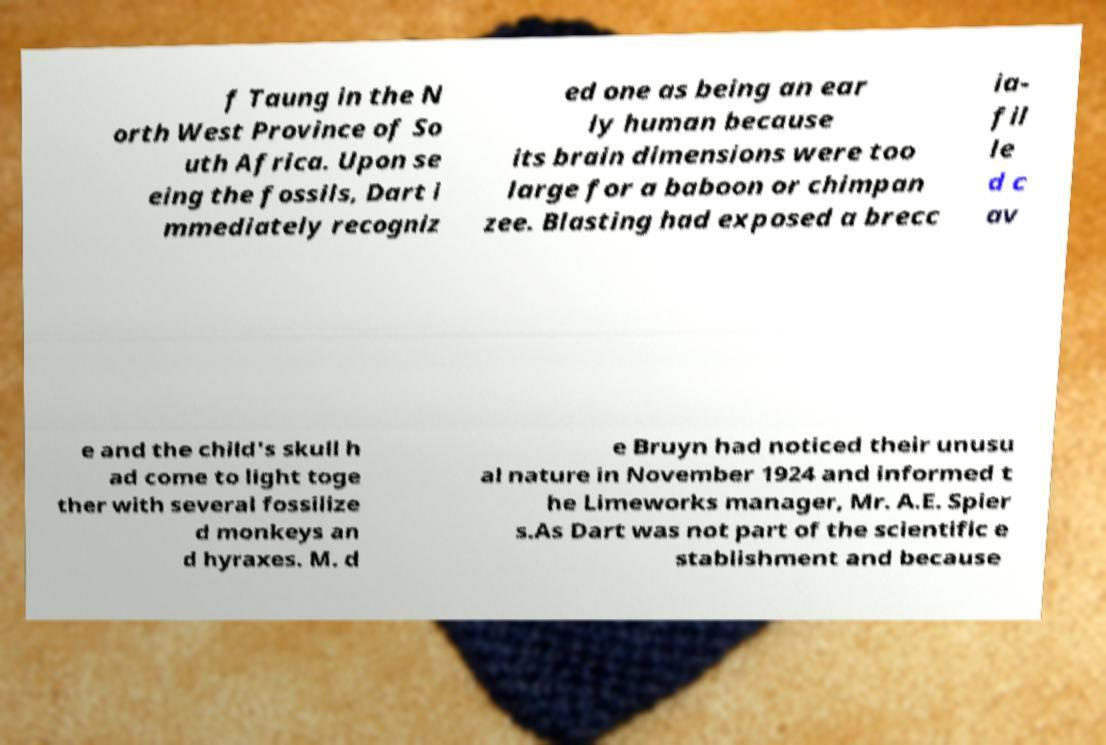Could you extract and type out the text from this image? f Taung in the N orth West Province of So uth Africa. Upon se eing the fossils, Dart i mmediately recogniz ed one as being an ear ly human because its brain dimensions were too large for a baboon or chimpan zee. Blasting had exposed a brecc ia- fil le d c av e and the child's skull h ad come to light toge ther with several fossilize d monkeys an d hyraxes. M. d e Bruyn had noticed their unusu al nature in November 1924 and informed t he Limeworks manager, Mr. A.E. Spier s.As Dart was not part of the scientific e stablishment and because 